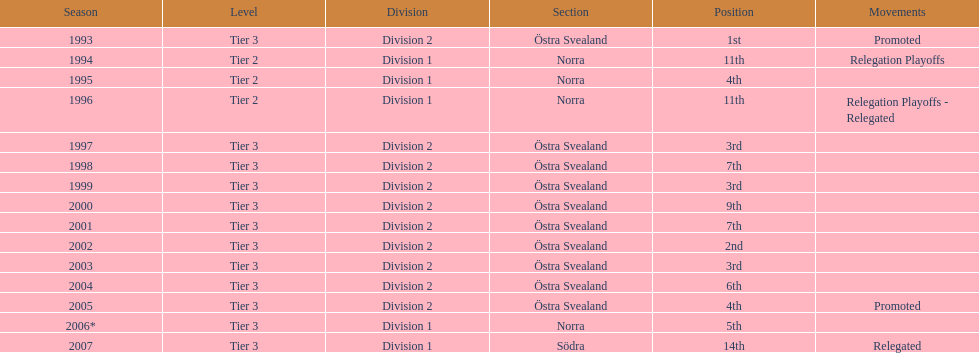What is the exclusive year with the 1st spot? 1993. 